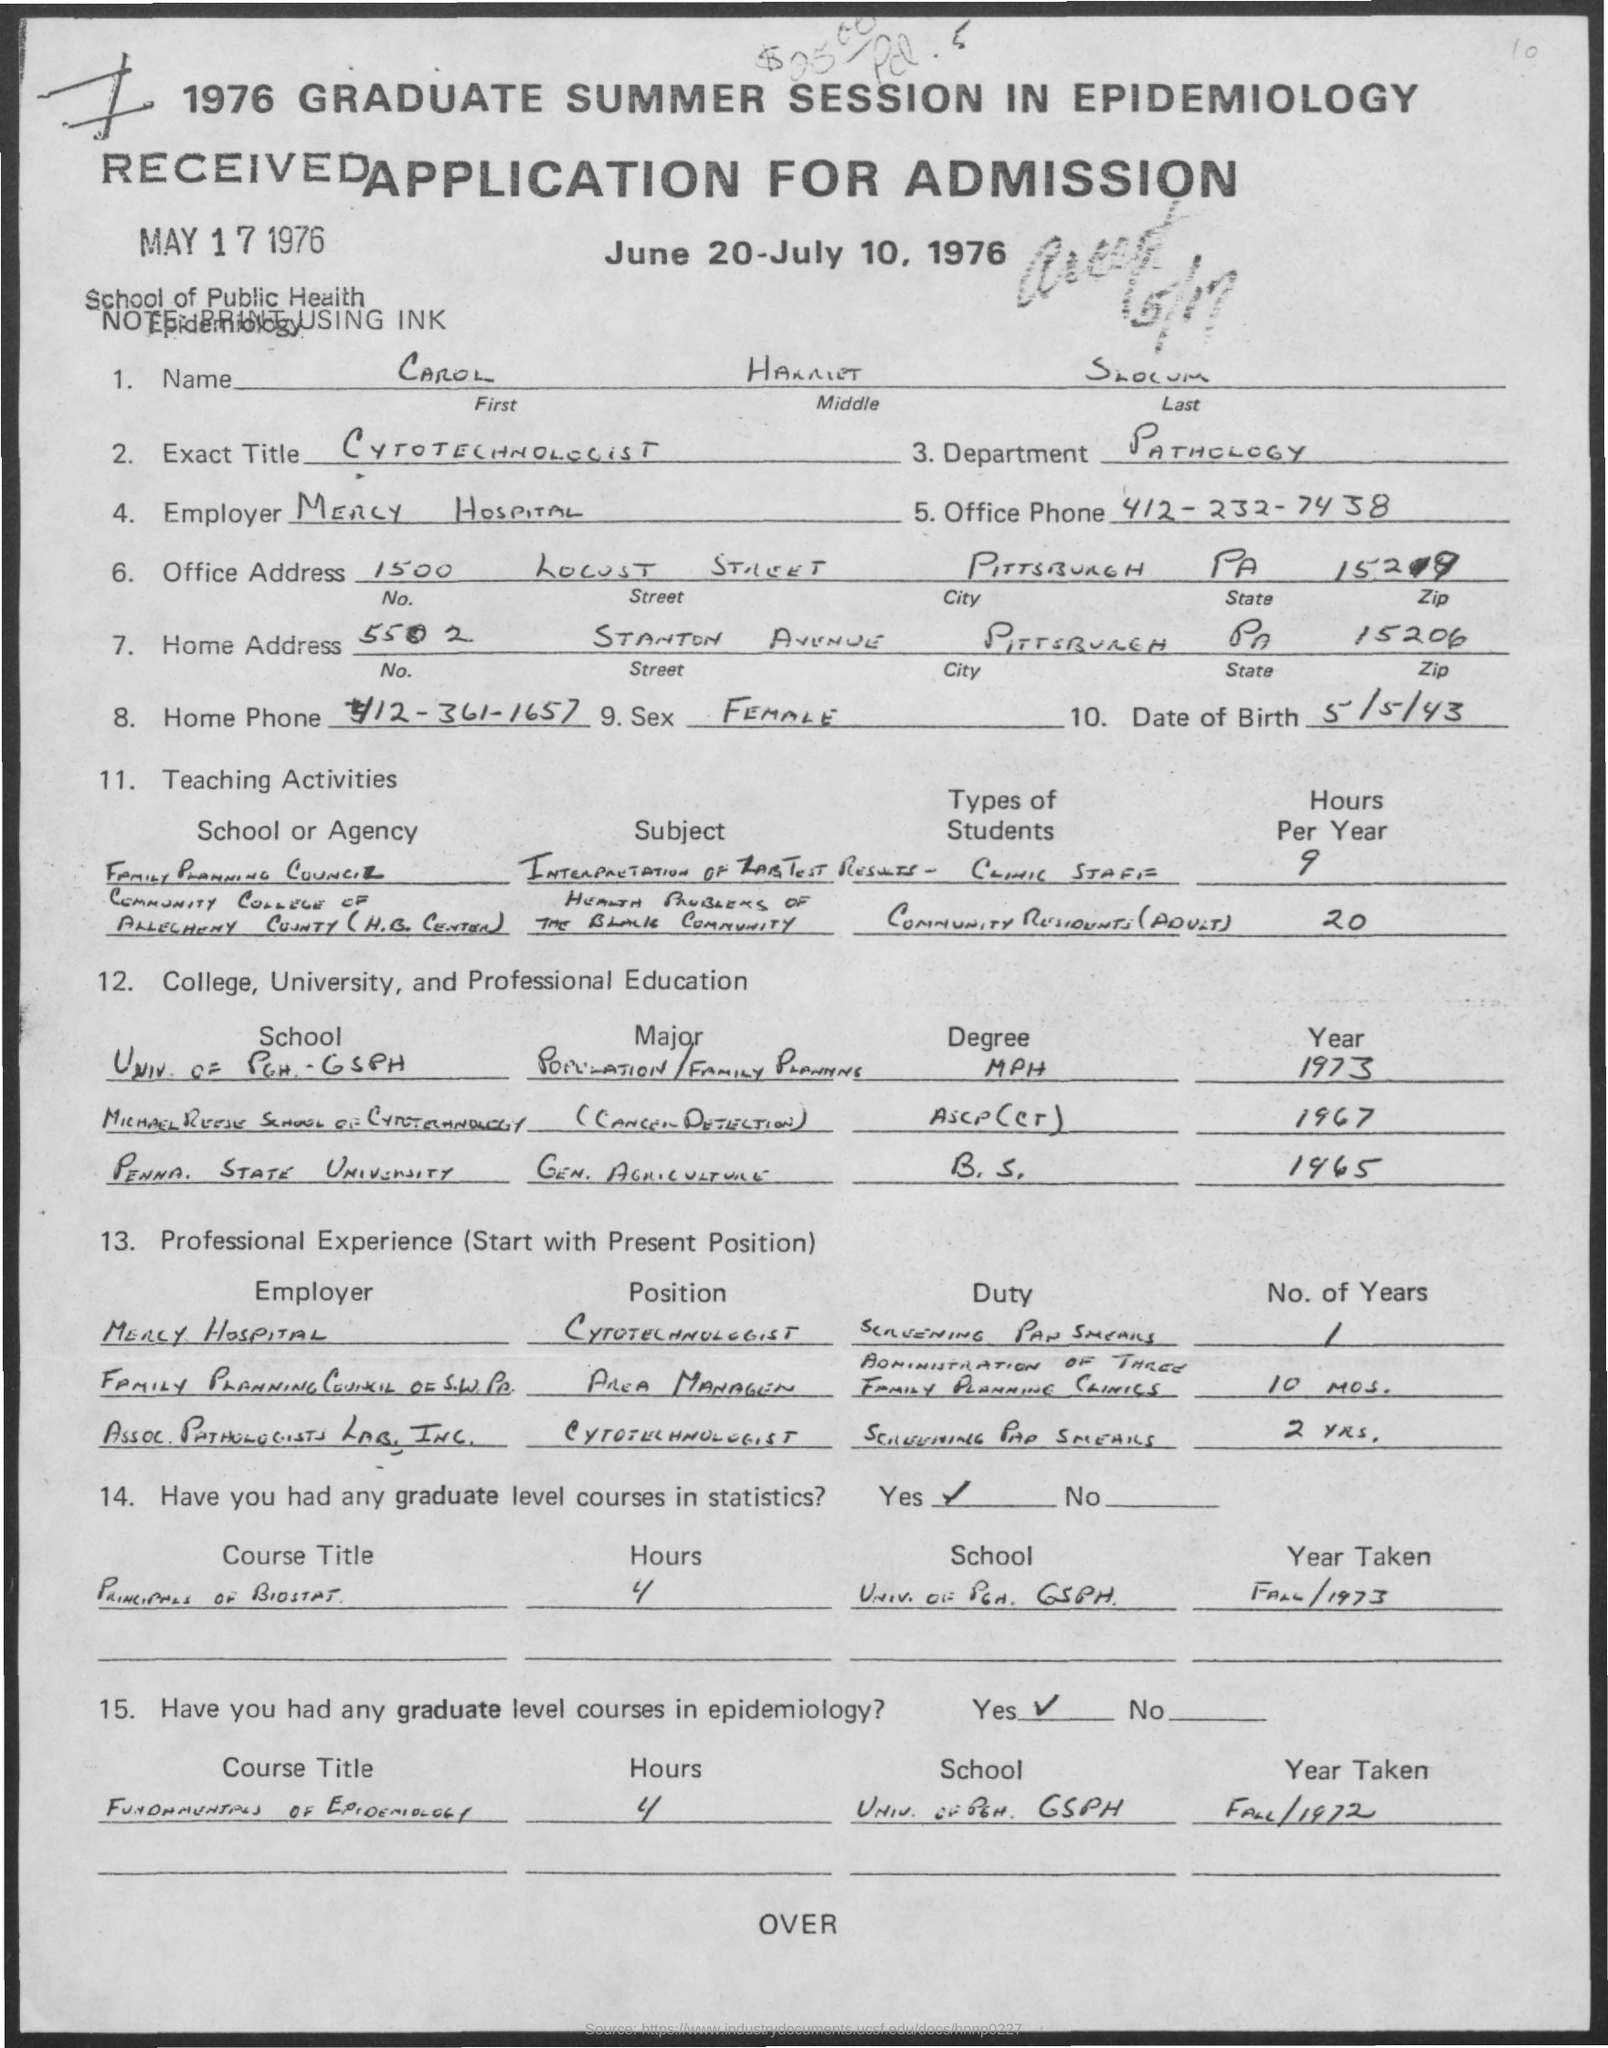Outline some significant characteristics in this image. The office phone number is 412-232-7438. The middle name is Harriet. It is Pittsburgh, the city that is being asked about. The Department is Pathology. The application was received on May 17, 1976. 